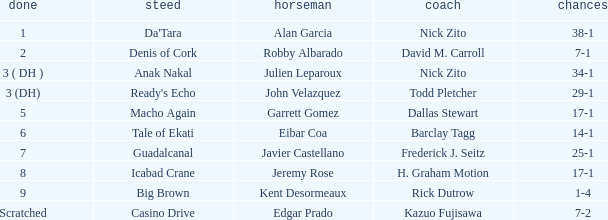What are the Odds for the Horse called Ready's Echo? 29-1. Give me the full table as a dictionary. {'header': ['done', 'steed', 'horseman', 'coach', 'chances'], 'rows': [['1', "Da'Tara", 'Alan Garcia', 'Nick Zito', '38-1'], ['2', 'Denis of Cork', 'Robby Albarado', 'David M. Carroll', '7-1'], ['3 ( DH )', 'Anak Nakal', 'Julien Leparoux', 'Nick Zito', '34-1'], ['3 (DH)', "Ready's Echo", 'John Velazquez', 'Todd Pletcher', '29-1'], ['5', 'Macho Again', 'Garrett Gomez', 'Dallas Stewart', '17-1'], ['6', 'Tale of Ekati', 'Eibar Coa', 'Barclay Tagg', '14-1'], ['7', 'Guadalcanal', 'Javier Castellano', 'Frederick J. Seitz', '25-1'], ['8', 'Icabad Crane', 'Jeremy Rose', 'H. Graham Motion', '17-1'], ['9', 'Big Brown', 'Kent Desormeaux', 'Rick Dutrow', '1-4'], ['Scratched', 'Casino Drive', 'Edgar Prado', 'Kazuo Fujisawa', '7-2']]} 